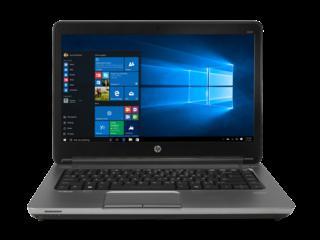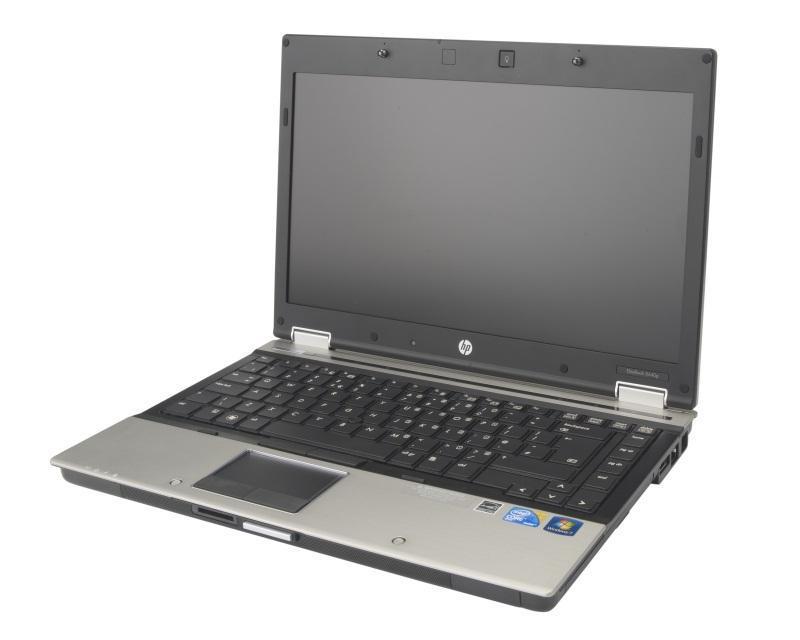The first image is the image on the left, the second image is the image on the right. Considering the images on both sides, is "The open laptop on the left is displayed head-on, while the one on the right is turned at an angle." valid? Answer yes or no. Yes. The first image is the image on the left, the second image is the image on the right. Given the left and right images, does the statement "Every single laptop appears to be powered on right now." hold true? Answer yes or no. No. 